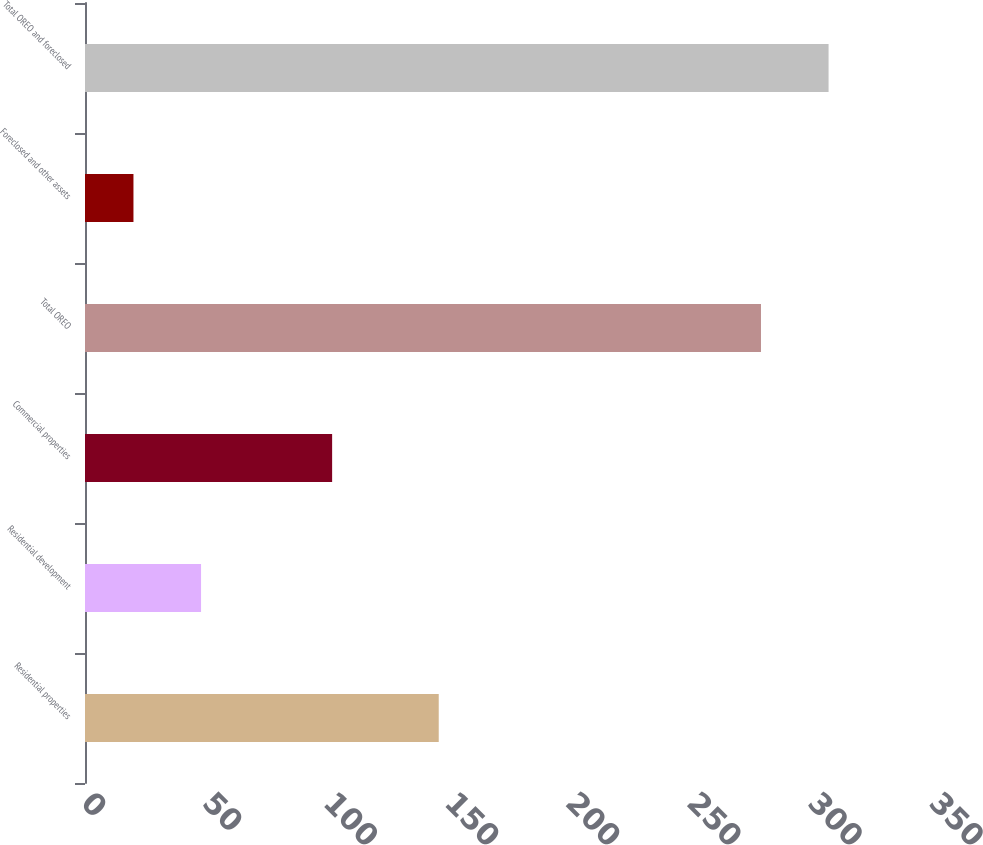<chart> <loc_0><loc_0><loc_500><loc_500><bar_chart><fcel>Residential properties<fcel>Residential development<fcel>Commercial properties<fcel>Total OREO<fcel>Foreclosed and other assets<fcel>Total OREO and foreclosed<nl><fcel>146<fcel>47.9<fcel>102<fcel>279<fcel>20<fcel>306.9<nl></chart> 